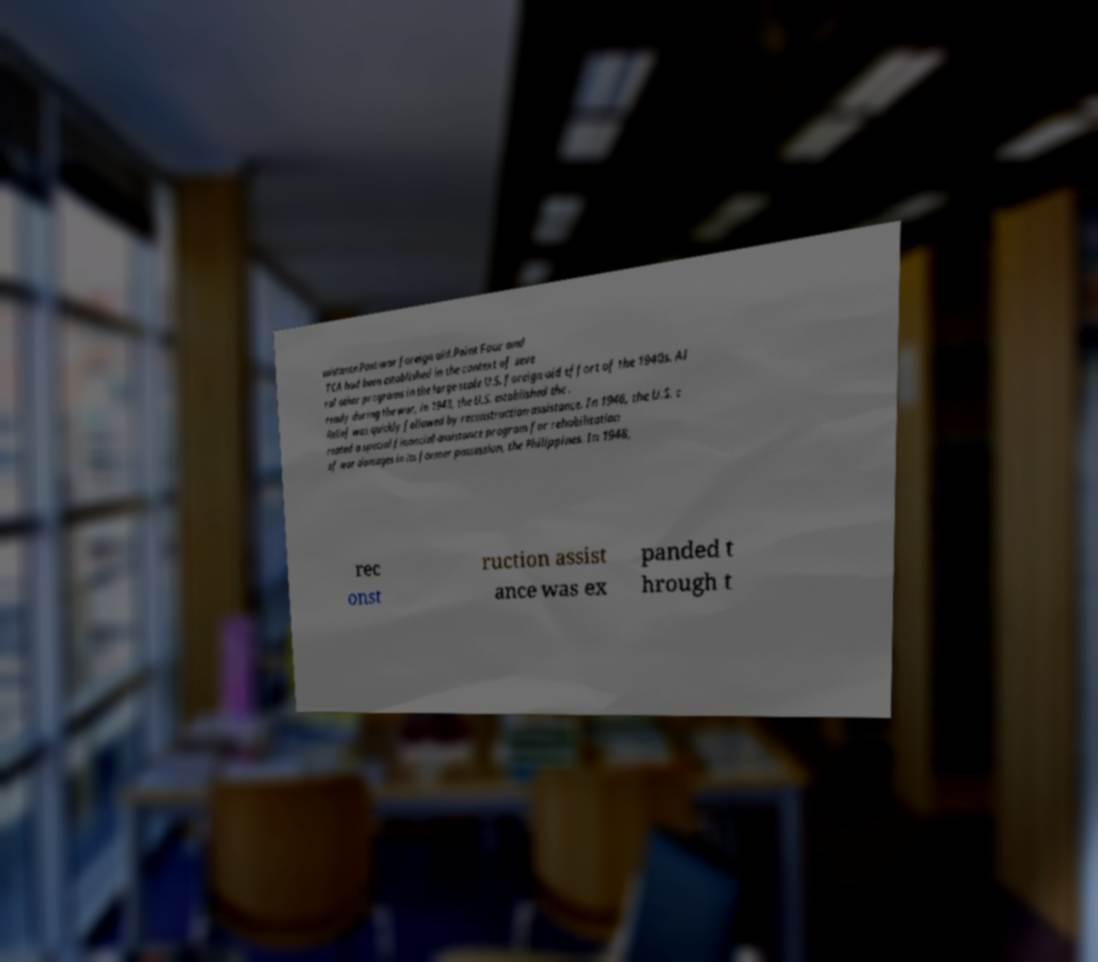Can you accurately transcribe the text from the provided image for me? ssistance.Post-war foreign aid.Point Four and TCA had been established in the context of seve ral other programs in the large-scale U.S. foreign aid effort of the 1940s. Al ready during the war, in 1943, the U.S. established the . Relief was quickly followed by reconstruction assistance. In 1946, the U.S. c reated a special financial-assistance program for rehabilitation of war damages in its former possession, the Philippines. In 1948, rec onst ruction assist ance was ex panded t hrough t 